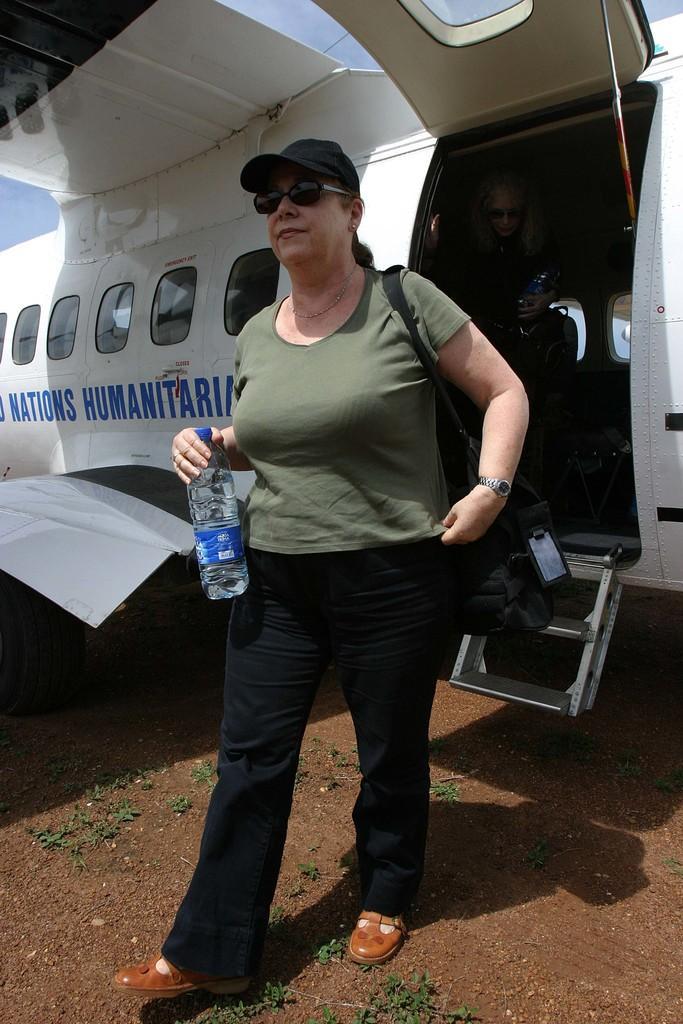Describe this image in one or two sentences. Here is the woman holding water bottle and walking. She wore T-shirt,trouser,goggles,cap and bag. This is the airplane. These are the windows. I can see another person inside the airplane. This looks like a door. 